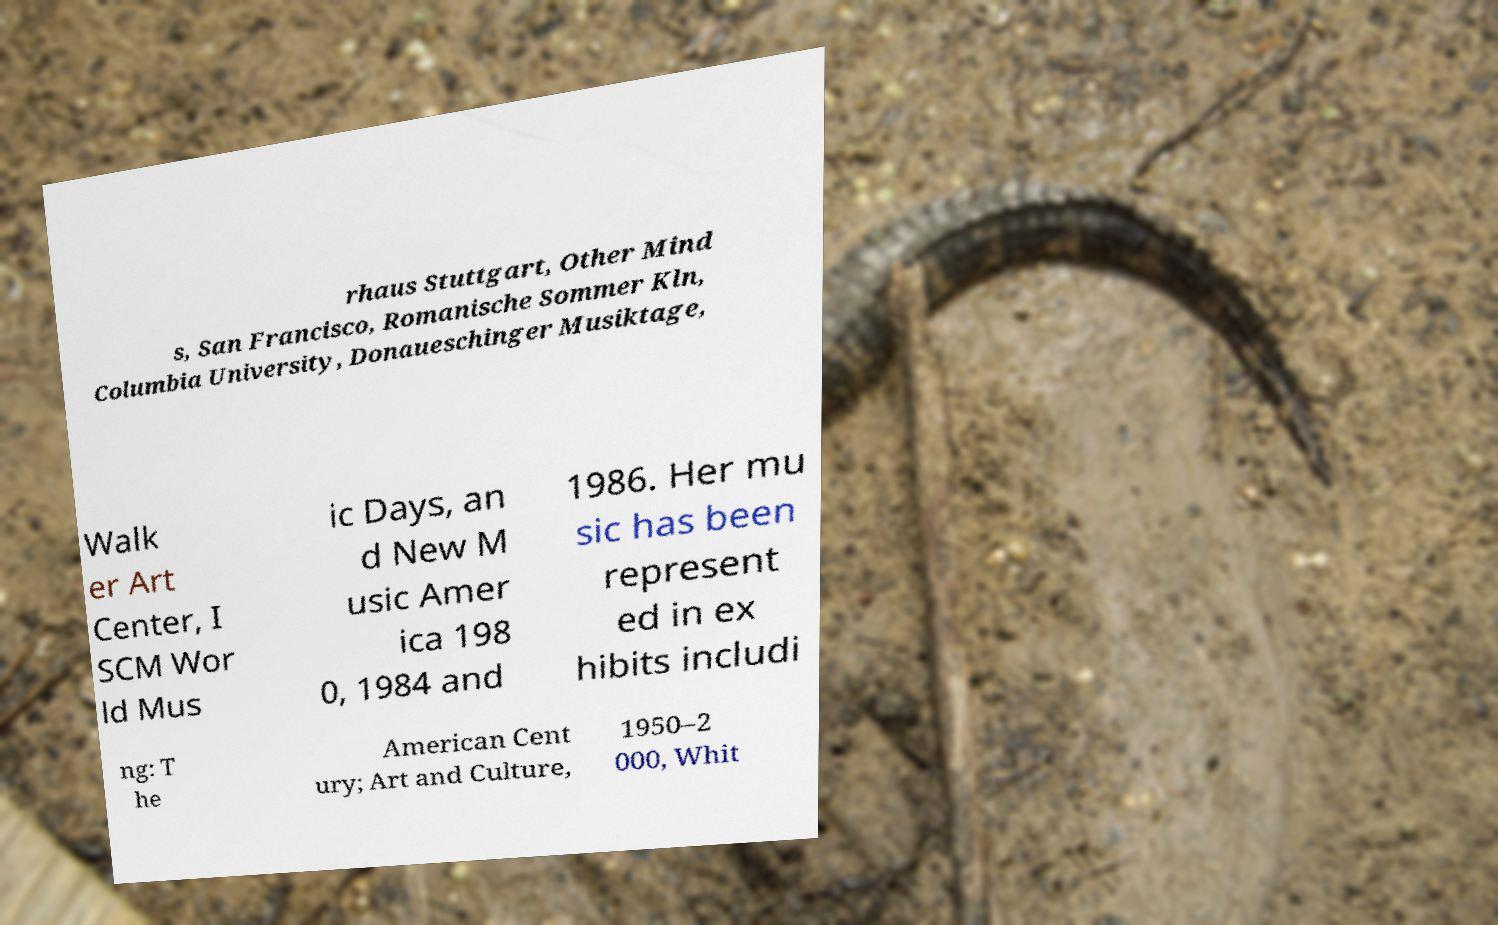What messages or text are displayed in this image? I need them in a readable, typed format. rhaus Stuttgart, Other Mind s, San Francisco, Romanische Sommer Kln, Columbia University, Donaueschinger Musiktage, Walk er Art Center, I SCM Wor ld Mus ic Days, an d New M usic Amer ica 198 0, 1984 and 1986. Her mu sic has been represent ed in ex hibits includi ng: T he American Cent ury; Art and Culture, 1950–2 000, Whit 